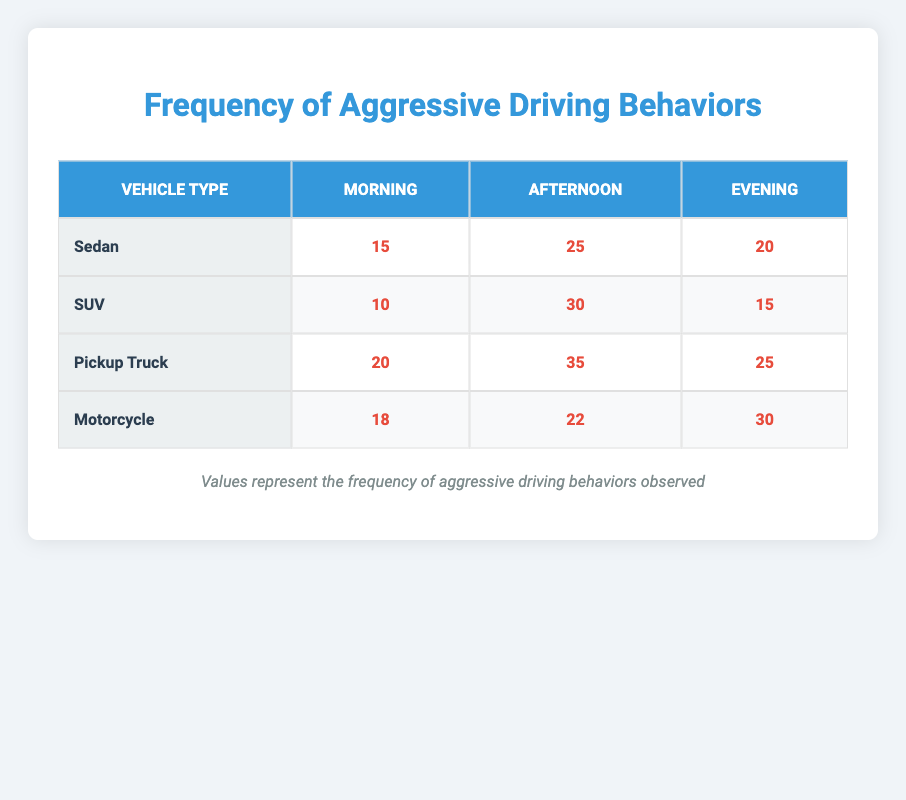What is the frequency of aggressive driving behaviors for Sedans in the Afternoon? The table shows that the frequency for Sedans in the Afternoon is directly listed under the corresponding row and column, which indicates 25.
Answer: 25 Which vehicle type has the highest frequency of aggressive driving behaviors during the Morning? By comparing the frequencies in the Morning column, Sedans (15), SUVs (10), Pickup Trucks (20), and Motorcycles (18) are listed. The highest value is for Pickup Trucks, which is 20.
Answer: Pickup Truck What is the total frequency of aggressive driving behaviors observed for Pickup Trucks across all times of day? To find this total, I add the frequencies: 20 (Morning) + 35 (Afternoon) + 25 (Evening) = 80.
Answer: 80 Is the frequency of aggressive driving behaviors higher in the Afternoon for SUVs than for Motorcycles? The frequency for SUVs in the Afternoon is 30, and for Motorcycles, it is 22. Since 30 is greater than 22, the statement is true.
Answer: Yes What is the average frequency of aggressive driving behaviors across all vehicle types in the Evening? First, I need to find the frequencies for each vehicle type in the Evening: Sedan (20), SUV (15), Pickup Truck (25), and Motorcycle (30). The total is 20 + 15 + 25 + 30 = 90. Since there are 4 vehicle types, the average is 90 / 4 = 22.5.
Answer: 22.5 Which time of day has the highest total frequency of aggressive driving behaviors across all vehicle types? To find this, I will sum up the frequencies for each time of day: Morning (15 + 10 + 20 + 18 = 63), Afternoon (25 + 30 + 35 + 22 = 112), Evening (20 + 15 + 25 + 30 = 90). The Afternoon has the highest total of 112.
Answer: Afternoon What is the difference in aggressive driving frequency between the highest and lowest vehicle types in the Afternoon? In the Afternoon, Pickup Trucks have the highest frequency (35), while SUVs have the lowest (30). The difference is 35 - 30 = 5.
Answer: 5 Are there more aggressive driving behaviors in the Evening than in the Morning for all vehicle types combined? Summing frequencies for the Evening: 20 (Sedan) + 15 (SUV) + 25 (Pickup Truck) + 30 (Motorcycle) = 90. For the Morning: 15 (Sedan) + 10 (SUV) + 20 (Pickup Truck) + 18 (Motorcycle) = 63. Since 90 is greater than 63, the statement is true.
Answer: Yes 